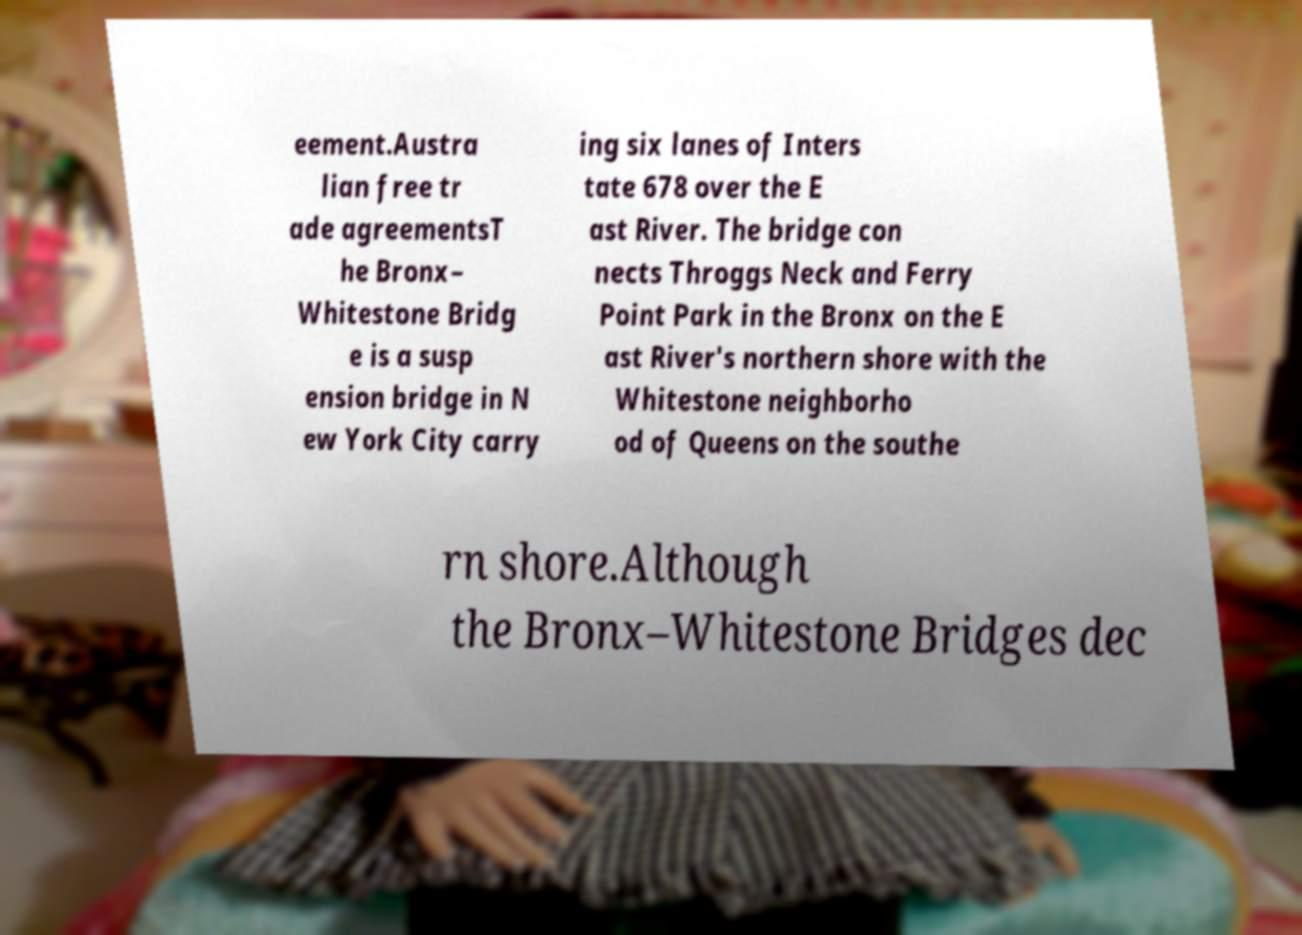Can you read and provide the text displayed in the image?This photo seems to have some interesting text. Can you extract and type it out for me? eement.Austra lian free tr ade agreementsT he Bronx– Whitestone Bridg e is a susp ension bridge in N ew York City carry ing six lanes of Inters tate 678 over the E ast River. The bridge con nects Throggs Neck and Ferry Point Park in the Bronx on the E ast River's northern shore with the Whitestone neighborho od of Queens on the southe rn shore.Although the Bronx–Whitestone Bridges dec 